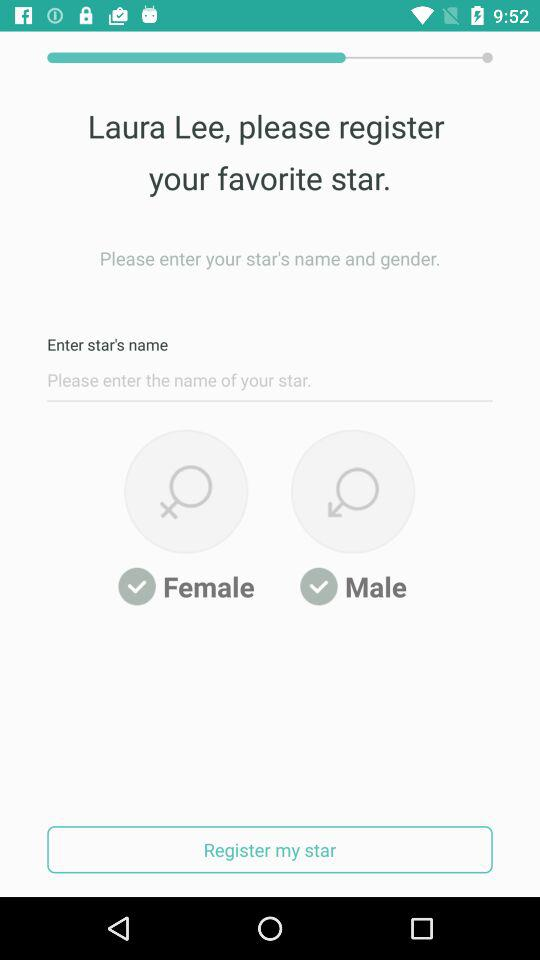What is the user name? The user name is Laura Lee. 